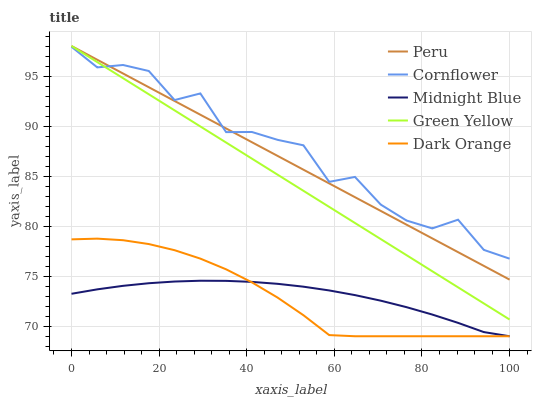Does Dark Orange have the minimum area under the curve?
Answer yes or no. Yes. Does Cornflower have the maximum area under the curve?
Answer yes or no. Yes. Does Green Yellow have the minimum area under the curve?
Answer yes or no. No. Does Green Yellow have the maximum area under the curve?
Answer yes or no. No. Is Peru the smoothest?
Answer yes or no. Yes. Is Cornflower the roughest?
Answer yes or no. Yes. Is Green Yellow the smoothest?
Answer yes or no. No. Is Green Yellow the roughest?
Answer yes or no. No. Does Green Yellow have the lowest value?
Answer yes or no. No. Does Peru have the highest value?
Answer yes or no. Yes. Does Midnight Blue have the highest value?
Answer yes or no. No. Is Dark Orange less than Green Yellow?
Answer yes or no. Yes. Is Cornflower greater than Dark Orange?
Answer yes or no. Yes. Does Dark Orange intersect Green Yellow?
Answer yes or no. No. 